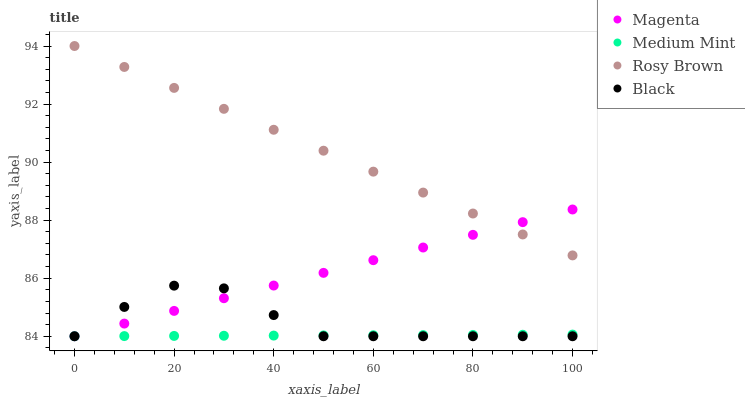Does Medium Mint have the minimum area under the curve?
Answer yes or no. Yes. Does Rosy Brown have the maximum area under the curve?
Answer yes or no. Yes. Does Magenta have the minimum area under the curve?
Answer yes or no. No. Does Magenta have the maximum area under the curve?
Answer yes or no. No. Is Magenta the smoothest?
Answer yes or no. Yes. Is Black the roughest?
Answer yes or no. Yes. Is Rosy Brown the smoothest?
Answer yes or no. No. Is Rosy Brown the roughest?
Answer yes or no. No. Does Medium Mint have the lowest value?
Answer yes or no. Yes. Does Rosy Brown have the lowest value?
Answer yes or no. No. Does Rosy Brown have the highest value?
Answer yes or no. Yes. Does Magenta have the highest value?
Answer yes or no. No. Is Black less than Rosy Brown?
Answer yes or no. Yes. Is Rosy Brown greater than Medium Mint?
Answer yes or no. Yes. Does Magenta intersect Medium Mint?
Answer yes or no. Yes. Is Magenta less than Medium Mint?
Answer yes or no. No. Is Magenta greater than Medium Mint?
Answer yes or no. No. Does Black intersect Rosy Brown?
Answer yes or no. No. 